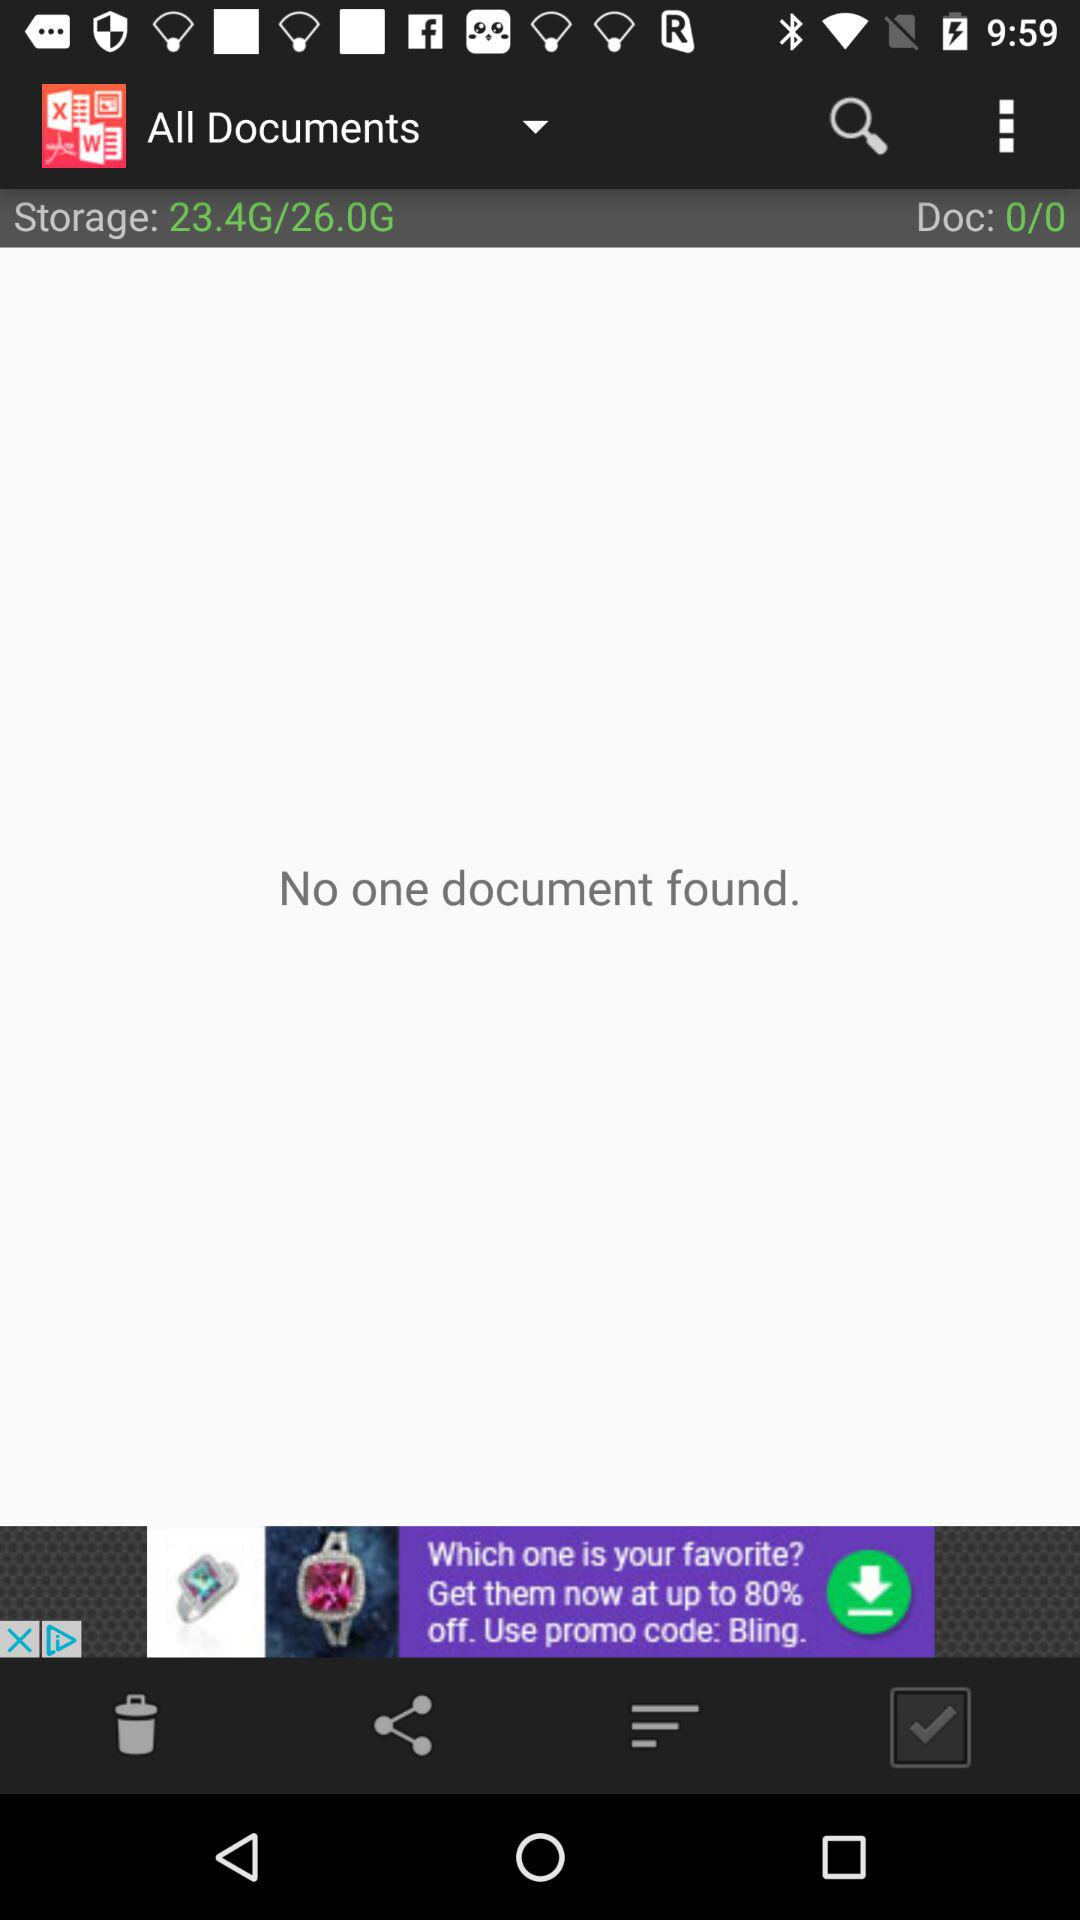How many documents are there?
Answer the question using a single word or phrase. 0 